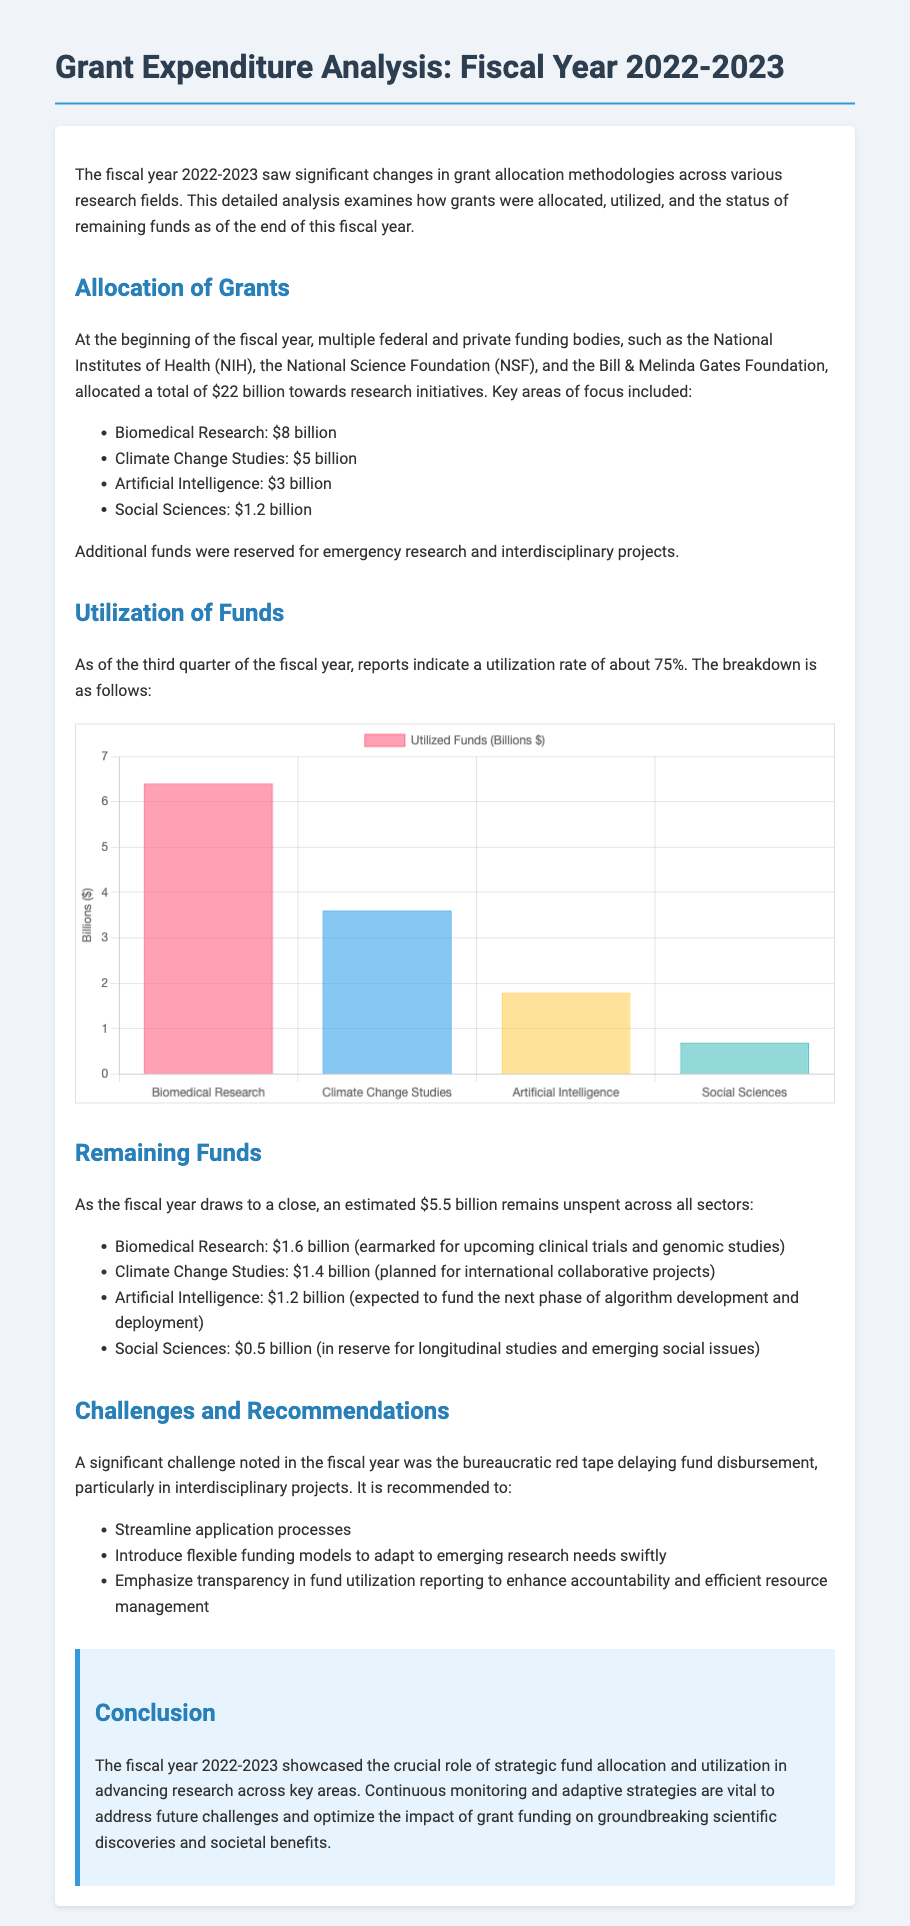What was the total amount allocated for research initiatives? The total allocated amount as stated in the document is $22 billion.
Answer: $22 billion What is the utilization rate of funds as of the third quarter? The document specifies that the utilization rate of funds is about 75%.
Answer: 75% How much of the Biomedical Research funds remains unspent? According to the document, $1.6 billion remains unspent in Biomedical Research.
Answer: $1.6 billion Which funding body allocated funds specifically for Climate Change Studies? The document mentions the National Science Foundation (NSF) among others as a funding body.
Answer: National Science Foundation What are the recommended strategies to tackle challenges noted in the fiscal year? The document lists recommendations such as streamlining application processes among others.
Answer: Streamline application processes What is the expected next phase for remaining funds in Artificial Intelligence? The document indicates that the remaining funds are expected to fund the next phase of algorithm development and deployment.
Answer: Next phase of algorithm development and deployment Which research area received the least amount of funding? The document states that Social Sciences received the least amount, which is $1.2 billion.
Answer: Social Sciences What was the primary challenge noted regarding fund disbursement? The document highlights bureaucratic red tape as a significant challenge impacting fund disbursement.
Answer: Bureaucratic red tape 